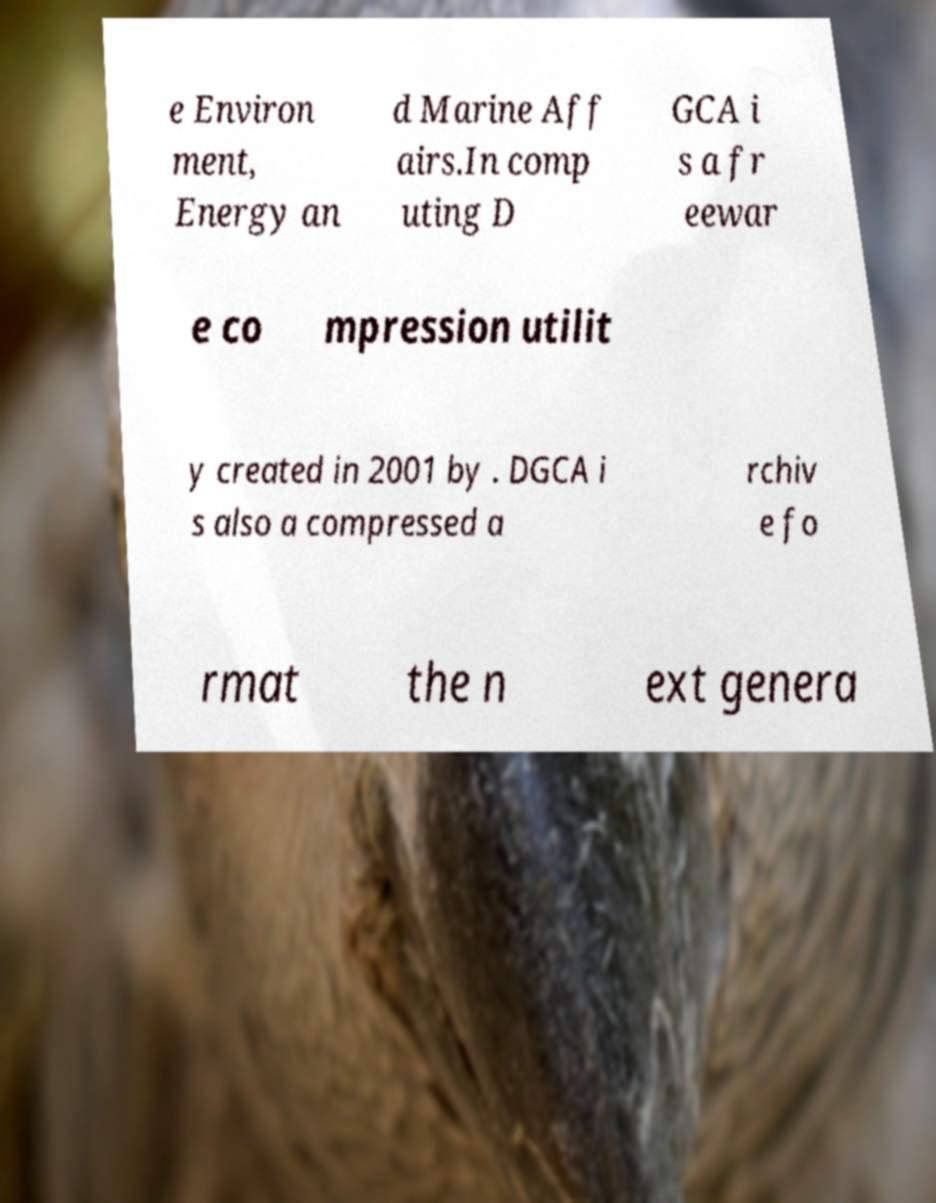There's text embedded in this image that I need extracted. Can you transcribe it verbatim? e Environ ment, Energy an d Marine Aff airs.In comp uting D GCA i s a fr eewar e co mpression utilit y created in 2001 by . DGCA i s also a compressed a rchiv e fo rmat the n ext genera 